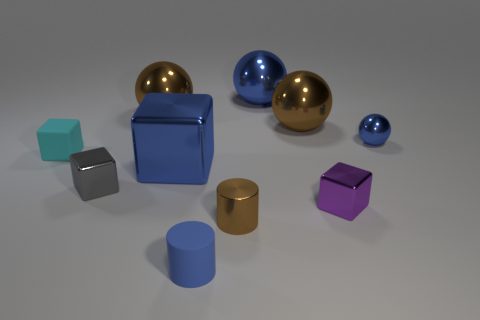What shape is the small thing that is the same color as the tiny matte cylinder?
Provide a short and direct response. Sphere. Do the brown object that is in front of the purple metallic block and the blue metal cube have the same size?
Ensure brevity in your answer.  No. What size is the blue cube that is the same material as the brown cylinder?
Keep it short and to the point. Large. Are there an equal number of big brown objects behind the blue cube and big blue metal objects?
Provide a succinct answer. Yes. Is the small metal sphere the same color as the matte cylinder?
Offer a very short reply. Yes. There is a thing on the left side of the small gray metal block; does it have the same shape as the large brown object that is to the right of the large blue cube?
Offer a very short reply. No. What material is the gray object that is the same shape as the small cyan object?
Your answer should be compact. Metal. What color is the big object that is both left of the tiny brown shiny object and behind the large blue cube?
Offer a terse response. Brown. There is a big brown object in front of the big brown metal object that is on the left side of the shiny cylinder; are there any metal things behind it?
Your response must be concise. Yes. How many things are small brown blocks or tiny blue rubber objects?
Offer a very short reply. 1. 